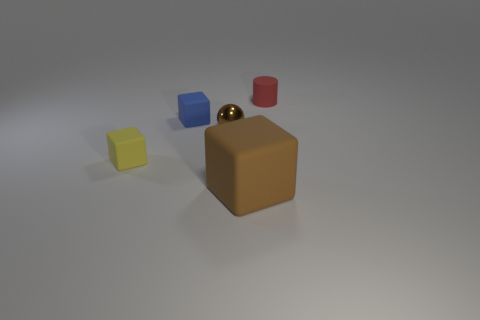There is a large brown thing that is the same shape as the small blue object; what is it made of?
Ensure brevity in your answer.  Rubber. What material is the small ball that is the same color as the large rubber object?
Provide a short and direct response. Metal. Is the number of tiny rubber cubes less than the number of small red objects?
Make the answer very short. No. There is a matte block that is in front of the yellow thing; is it the same color as the small rubber cylinder?
Your response must be concise. No. What color is the big object that is made of the same material as the small cylinder?
Make the answer very short. Brown. Is the size of the red matte thing the same as the brown metallic ball?
Offer a terse response. Yes. What material is the yellow block?
Your response must be concise. Rubber. There is a brown object that is the same size as the blue block; what is its material?
Your answer should be very brief. Metal. Are there any shiny balls that have the same size as the blue block?
Ensure brevity in your answer.  Yes. Are there an equal number of metallic balls in front of the ball and big brown cubes to the right of the red matte object?
Ensure brevity in your answer.  Yes. 